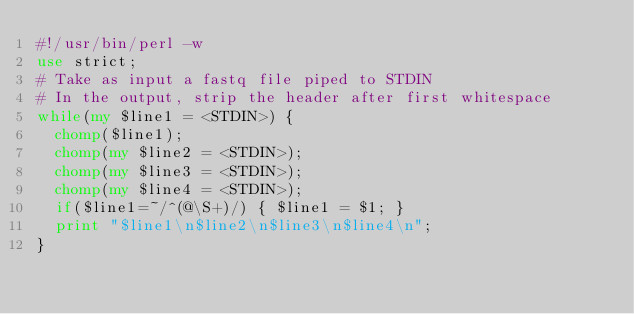Convert code to text. <code><loc_0><loc_0><loc_500><loc_500><_Perl_>#!/usr/bin/perl -w
use strict;
# Take as input a fastq file piped to STDIN
# In the output, strip the header after first whitespace
while(my $line1 = <STDIN>) {
  chomp($line1);
  chomp(my $line2 = <STDIN>);
  chomp(my $line3 = <STDIN>);
  chomp(my $line4 = <STDIN>);
  if($line1=~/^(@\S+)/) { $line1 = $1; }
  print "$line1\n$line2\n$line3\n$line4\n";
}
</code> 